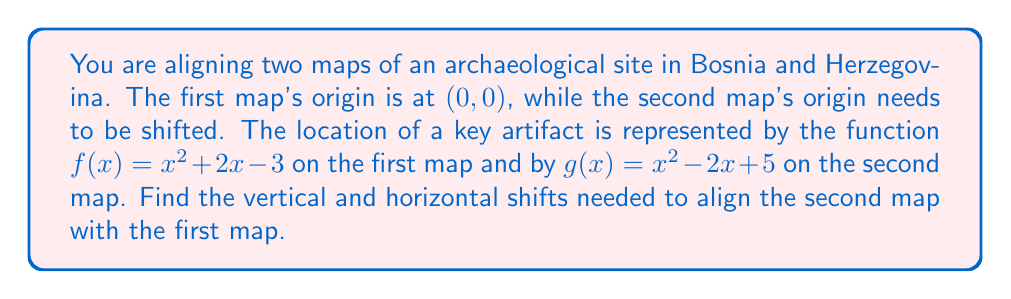Help me with this question. To align the two maps, we need to find the horizontal and vertical shifts that transform $g(x)$ into $f(x)$. Let's approach this step-by-step:

1) The general form of a quadratic function is $ax^2 + bx + c$. In this case, both functions have $a=1$, so we only need to focus on the linear term and the constant.

2) For $f(x) = x^2 + 2x - 3$ and $g(x) = x^2 - 2x + 5$, we can rewrite $g(x)$ in terms of $f(x)$ with horizontal and vertical shifts:

   $g(x) = f(x + h) + k$, where $h$ is the horizontal shift and $k$ is the vertical shift.

3) Expanding $f(x + h)$:
   $f(x + h) = (x + h)^2 + 2(x + h) - 3$
              $= x^2 + 2hx + h^2 + 2x + 2h - 3$
              $= x^2 + (2h + 2)x + (h^2 + 2h - 3)$

4) Now, $f(x + h) + k = x^2 + (2h + 2)x + (h^2 + 2h - 3 + k)$

5) This should equal $g(x) = x^2 - 2x + 5$. Comparing coefficients:

   $2h + 2 = -2$
   $h^2 + 2h - 3 + k = 5$

6) From the first equation:
   $2h = -4$
   $h = -2$

7) Substituting this into the second equation:
   $(-2)^2 + 2(-2) - 3 + k = 5$
   $4 - 4 - 3 + k = 5$
   $-3 + k = 5$
   $k = 8$

Therefore, the horizontal shift is -2 units (2 units left) and the vertical shift is 8 units up.
Answer: Horizontal shift: -2 units (left)
Vertical shift: 8 units (up) 